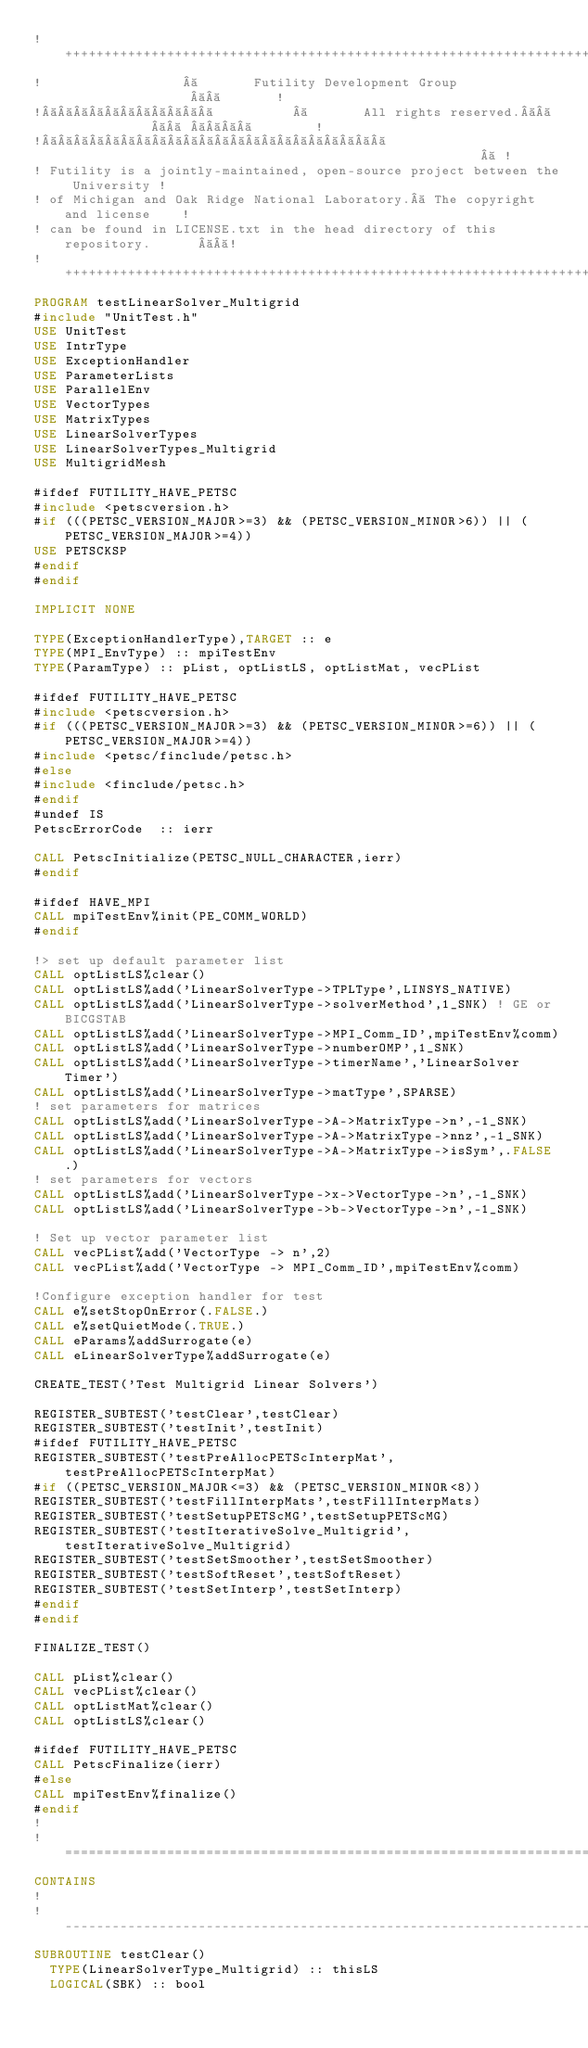Convert code to text. <code><loc_0><loc_0><loc_500><loc_500><_FORTRAN_>!++++++++++++++++++++++++++++++++++++++++++++++++++++++++++++++++++++++++++++++!
!                          Futility Development Group                          !
!                             All rights reserved.                             !
!                                                                              !
! Futility is a jointly-maintained, open-source project between the University !
! of Michigan and Oak Ridge National Laboratory.  The copyright and license    !
! can be found in LICENSE.txt in the head directory of this repository.        !
!++++++++++++++++++++++++++++++++++++++++++++++++++++++++++++++++++++++++++++++!
PROGRAM testLinearSolver_Multigrid
#include "UnitTest.h"
USE UnitTest
USE IntrType
USE ExceptionHandler
USE ParameterLists
USE ParallelEnv
USE VectorTypes
USE MatrixTypes
USE LinearSolverTypes
USE LinearSolverTypes_Multigrid
USE MultigridMesh

#ifdef FUTILITY_HAVE_PETSC
#include <petscversion.h>
#if (((PETSC_VERSION_MAJOR>=3) && (PETSC_VERSION_MINOR>6)) || (PETSC_VERSION_MAJOR>=4))
USE PETSCKSP
#endif
#endif

IMPLICIT NONE

TYPE(ExceptionHandlerType),TARGET :: e
TYPE(MPI_EnvType) :: mpiTestEnv
TYPE(ParamType) :: pList, optListLS, optListMat, vecPList

#ifdef FUTILITY_HAVE_PETSC
#include <petscversion.h>
#if (((PETSC_VERSION_MAJOR>=3) && (PETSC_VERSION_MINOR>=6)) || (PETSC_VERSION_MAJOR>=4))
#include <petsc/finclude/petsc.h>
#else
#include <finclude/petsc.h>
#endif
#undef IS
PetscErrorCode  :: ierr

CALL PetscInitialize(PETSC_NULL_CHARACTER,ierr)
#endif

#ifdef HAVE_MPI
CALL mpiTestEnv%init(PE_COMM_WORLD)
#endif

!> set up default parameter list
CALL optListLS%clear()
CALL optListLS%add('LinearSolverType->TPLType',LINSYS_NATIVE)
CALL optListLS%add('LinearSolverType->solverMethod',1_SNK) ! GE or BICGSTAB
CALL optListLS%add('LinearSolverType->MPI_Comm_ID',mpiTestEnv%comm)
CALL optListLS%add('LinearSolverType->numberOMP',1_SNK)
CALL optListLS%add('LinearSolverType->timerName','LinearSolver Timer')
CALL optListLS%add('LinearSolverType->matType',SPARSE)
! set parameters for matrices
CALL optListLS%add('LinearSolverType->A->MatrixType->n',-1_SNK)
CALL optListLS%add('LinearSolverType->A->MatrixType->nnz',-1_SNK)
CALL optListLS%add('LinearSolverType->A->MatrixType->isSym',.FALSE.)
! set parameters for vectors
CALL optListLS%add('LinearSolverType->x->VectorType->n',-1_SNK)
CALL optListLS%add('LinearSolverType->b->VectorType->n',-1_SNK)

! Set up vector parameter list
CALL vecPList%add('VectorType -> n',2)
CALL vecPList%add('VectorType -> MPI_Comm_ID',mpiTestEnv%comm)

!Configure exception handler for test
CALL e%setStopOnError(.FALSE.)
CALL e%setQuietMode(.TRUE.)
CALL eParams%addSurrogate(e)
CALL eLinearSolverType%addSurrogate(e)

CREATE_TEST('Test Multigrid Linear Solvers')

REGISTER_SUBTEST('testClear',testClear)
REGISTER_SUBTEST('testInit',testInit)
#ifdef FUTILITY_HAVE_PETSC
REGISTER_SUBTEST('testPreAllocPETScInterpMat',testPreAllocPETScInterpMat)
#if ((PETSC_VERSION_MAJOR<=3) && (PETSC_VERSION_MINOR<8))
REGISTER_SUBTEST('testFillInterpMats',testFillInterpMats)
REGISTER_SUBTEST('testSetupPETScMG',testSetupPETScMG)
REGISTER_SUBTEST('testIterativeSolve_Multigrid',testIterativeSolve_Multigrid)
REGISTER_SUBTEST('testSetSmoother',testSetSmoother)
REGISTER_SUBTEST('testSoftReset',testSoftReset)
REGISTER_SUBTEST('testSetInterp',testSetInterp)
#endif
#endif

FINALIZE_TEST()

CALL pList%clear()
CALL vecPList%clear()
CALL optListMat%clear()
CALL optListLS%clear()

#ifdef FUTILITY_HAVE_PETSC
CALL PetscFinalize(ierr)
#else
CALL mpiTestEnv%finalize()
#endif
!
!===============================================================================
CONTAINS
!
!-------------------------------------------------------------------------------
SUBROUTINE testClear()
  TYPE(LinearSolverType_Multigrid) :: thisLS
  LOGICAL(SBK) :: bool
</code> 